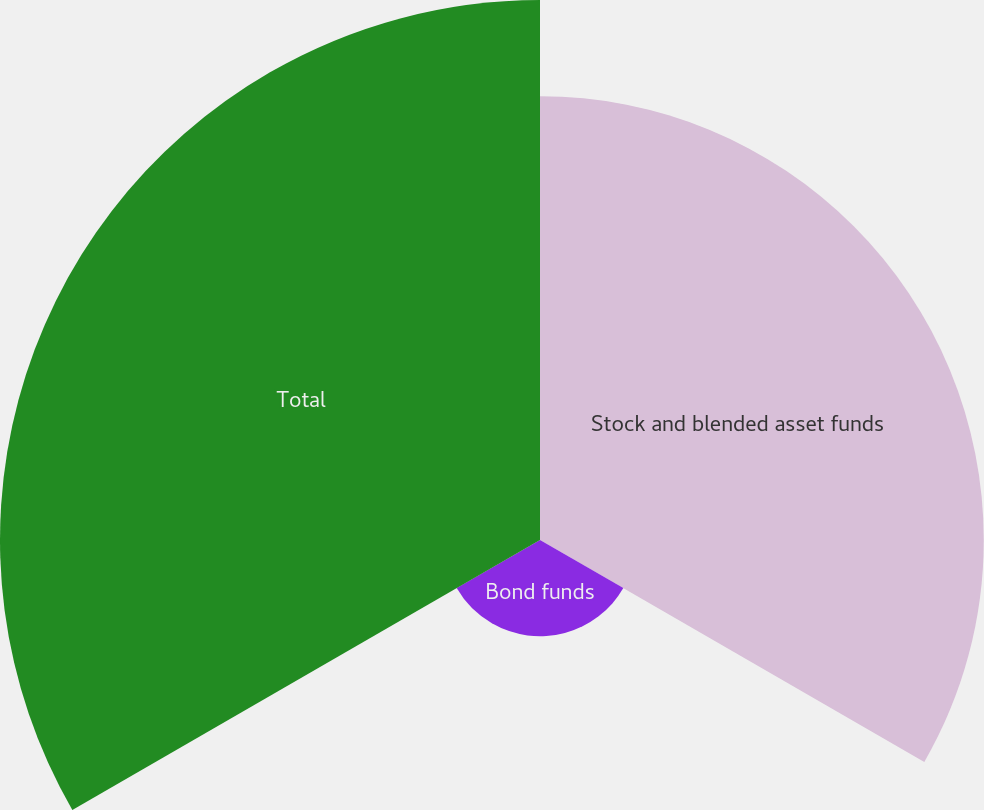Convert chart to OTSL. <chart><loc_0><loc_0><loc_500><loc_500><pie_chart><fcel>Stock and blended asset funds<fcel>Bond funds<fcel>Total<nl><fcel>41.09%<fcel>8.91%<fcel>50.0%<nl></chart> 